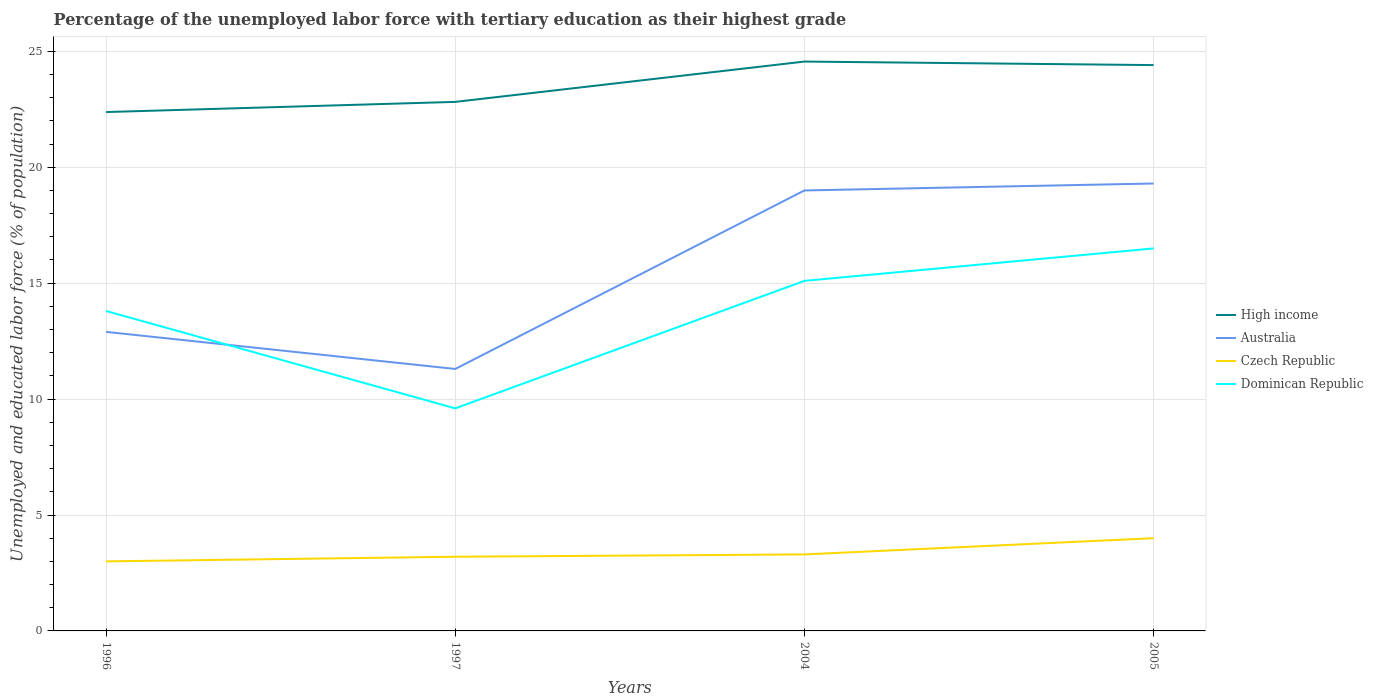Across all years, what is the maximum percentage of the unemployed labor force with tertiary education in Dominican Republic?
Make the answer very short. 9.6. What is the total percentage of the unemployed labor force with tertiary education in Australia in the graph?
Give a very brief answer. -8. What is the difference between the highest and the lowest percentage of the unemployed labor force with tertiary education in Dominican Republic?
Offer a very short reply. 3. How many years are there in the graph?
Your answer should be compact. 4. What is the difference between two consecutive major ticks on the Y-axis?
Ensure brevity in your answer.  5. How many legend labels are there?
Provide a succinct answer. 4. How are the legend labels stacked?
Offer a terse response. Vertical. What is the title of the graph?
Provide a short and direct response. Percentage of the unemployed labor force with tertiary education as their highest grade. Does "Lebanon" appear as one of the legend labels in the graph?
Your response must be concise. No. What is the label or title of the Y-axis?
Provide a short and direct response. Unemployed and educated labor force (% of population). What is the Unemployed and educated labor force (% of population) in High income in 1996?
Offer a very short reply. 22.38. What is the Unemployed and educated labor force (% of population) of Australia in 1996?
Ensure brevity in your answer.  12.9. What is the Unemployed and educated labor force (% of population) of Dominican Republic in 1996?
Offer a very short reply. 13.8. What is the Unemployed and educated labor force (% of population) of High income in 1997?
Make the answer very short. 22.82. What is the Unemployed and educated labor force (% of population) of Australia in 1997?
Provide a short and direct response. 11.3. What is the Unemployed and educated labor force (% of population) in Czech Republic in 1997?
Make the answer very short. 3.2. What is the Unemployed and educated labor force (% of population) of Dominican Republic in 1997?
Make the answer very short. 9.6. What is the Unemployed and educated labor force (% of population) of High income in 2004?
Offer a very short reply. 24.56. What is the Unemployed and educated labor force (% of population) of Australia in 2004?
Offer a very short reply. 19. What is the Unemployed and educated labor force (% of population) in Czech Republic in 2004?
Your response must be concise. 3.3. What is the Unemployed and educated labor force (% of population) of Dominican Republic in 2004?
Keep it short and to the point. 15.1. What is the Unemployed and educated labor force (% of population) of High income in 2005?
Offer a terse response. 24.41. What is the Unemployed and educated labor force (% of population) of Australia in 2005?
Provide a succinct answer. 19.3. What is the Unemployed and educated labor force (% of population) of Dominican Republic in 2005?
Your response must be concise. 16.5. Across all years, what is the maximum Unemployed and educated labor force (% of population) in High income?
Your response must be concise. 24.56. Across all years, what is the maximum Unemployed and educated labor force (% of population) of Australia?
Make the answer very short. 19.3. Across all years, what is the maximum Unemployed and educated labor force (% of population) in Czech Republic?
Offer a terse response. 4. Across all years, what is the maximum Unemployed and educated labor force (% of population) of Dominican Republic?
Your answer should be very brief. 16.5. Across all years, what is the minimum Unemployed and educated labor force (% of population) of High income?
Make the answer very short. 22.38. Across all years, what is the minimum Unemployed and educated labor force (% of population) of Australia?
Ensure brevity in your answer.  11.3. Across all years, what is the minimum Unemployed and educated labor force (% of population) of Dominican Republic?
Your response must be concise. 9.6. What is the total Unemployed and educated labor force (% of population) in High income in the graph?
Provide a short and direct response. 94.17. What is the total Unemployed and educated labor force (% of population) in Australia in the graph?
Your answer should be compact. 62.5. What is the total Unemployed and educated labor force (% of population) in Czech Republic in the graph?
Your answer should be very brief. 13.5. What is the total Unemployed and educated labor force (% of population) in Dominican Republic in the graph?
Your answer should be compact. 55. What is the difference between the Unemployed and educated labor force (% of population) in High income in 1996 and that in 1997?
Keep it short and to the point. -0.44. What is the difference between the Unemployed and educated labor force (% of population) in Australia in 1996 and that in 1997?
Make the answer very short. 1.6. What is the difference between the Unemployed and educated labor force (% of population) in Czech Republic in 1996 and that in 1997?
Offer a very short reply. -0.2. What is the difference between the Unemployed and educated labor force (% of population) in High income in 1996 and that in 2004?
Keep it short and to the point. -2.18. What is the difference between the Unemployed and educated labor force (% of population) of Czech Republic in 1996 and that in 2004?
Offer a terse response. -0.3. What is the difference between the Unemployed and educated labor force (% of population) in Dominican Republic in 1996 and that in 2004?
Provide a succinct answer. -1.3. What is the difference between the Unemployed and educated labor force (% of population) of High income in 1996 and that in 2005?
Offer a terse response. -2.03. What is the difference between the Unemployed and educated labor force (% of population) of Australia in 1996 and that in 2005?
Provide a short and direct response. -6.4. What is the difference between the Unemployed and educated labor force (% of population) in Czech Republic in 1996 and that in 2005?
Your answer should be compact. -1. What is the difference between the Unemployed and educated labor force (% of population) in Dominican Republic in 1996 and that in 2005?
Provide a succinct answer. -2.7. What is the difference between the Unemployed and educated labor force (% of population) in High income in 1997 and that in 2004?
Your response must be concise. -1.74. What is the difference between the Unemployed and educated labor force (% of population) in High income in 1997 and that in 2005?
Keep it short and to the point. -1.59. What is the difference between the Unemployed and educated labor force (% of population) in Australia in 1997 and that in 2005?
Offer a terse response. -8. What is the difference between the Unemployed and educated labor force (% of population) in Dominican Republic in 1997 and that in 2005?
Keep it short and to the point. -6.9. What is the difference between the Unemployed and educated labor force (% of population) of High income in 2004 and that in 2005?
Provide a succinct answer. 0.15. What is the difference between the Unemployed and educated labor force (% of population) of Australia in 2004 and that in 2005?
Provide a succinct answer. -0.3. What is the difference between the Unemployed and educated labor force (% of population) of Czech Republic in 2004 and that in 2005?
Offer a terse response. -0.7. What is the difference between the Unemployed and educated labor force (% of population) in Dominican Republic in 2004 and that in 2005?
Keep it short and to the point. -1.4. What is the difference between the Unemployed and educated labor force (% of population) in High income in 1996 and the Unemployed and educated labor force (% of population) in Australia in 1997?
Provide a succinct answer. 11.08. What is the difference between the Unemployed and educated labor force (% of population) of High income in 1996 and the Unemployed and educated labor force (% of population) of Czech Republic in 1997?
Offer a very short reply. 19.18. What is the difference between the Unemployed and educated labor force (% of population) in High income in 1996 and the Unemployed and educated labor force (% of population) in Dominican Republic in 1997?
Ensure brevity in your answer.  12.78. What is the difference between the Unemployed and educated labor force (% of population) of Australia in 1996 and the Unemployed and educated labor force (% of population) of Dominican Republic in 1997?
Your response must be concise. 3.3. What is the difference between the Unemployed and educated labor force (% of population) in Czech Republic in 1996 and the Unemployed and educated labor force (% of population) in Dominican Republic in 1997?
Keep it short and to the point. -6.6. What is the difference between the Unemployed and educated labor force (% of population) in High income in 1996 and the Unemployed and educated labor force (% of population) in Australia in 2004?
Your answer should be very brief. 3.38. What is the difference between the Unemployed and educated labor force (% of population) of High income in 1996 and the Unemployed and educated labor force (% of population) of Czech Republic in 2004?
Provide a succinct answer. 19.08. What is the difference between the Unemployed and educated labor force (% of population) in High income in 1996 and the Unemployed and educated labor force (% of population) in Dominican Republic in 2004?
Provide a short and direct response. 7.28. What is the difference between the Unemployed and educated labor force (% of population) of High income in 1996 and the Unemployed and educated labor force (% of population) of Australia in 2005?
Your answer should be very brief. 3.08. What is the difference between the Unemployed and educated labor force (% of population) in High income in 1996 and the Unemployed and educated labor force (% of population) in Czech Republic in 2005?
Give a very brief answer. 18.38. What is the difference between the Unemployed and educated labor force (% of population) of High income in 1996 and the Unemployed and educated labor force (% of population) of Dominican Republic in 2005?
Offer a terse response. 5.88. What is the difference between the Unemployed and educated labor force (% of population) in Australia in 1996 and the Unemployed and educated labor force (% of population) in Czech Republic in 2005?
Provide a succinct answer. 8.9. What is the difference between the Unemployed and educated labor force (% of population) of Australia in 1996 and the Unemployed and educated labor force (% of population) of Dominican Republic in 2005?
Make the answer very short. -3.6. What is the difference between the Unemployed and educated labor force (% of population) in Czech Republic in 1996 and the Unemployed and educated labor force (% of population) in Dominican Republic in 2005?
Ensure brevity in your answer.  -13.5. What is the difference between the Unemployed and educated labor force (% of population) in High income in 1997 and the Unemployed and educated labor force (% of population) in Australia in 2004?
Your answer should be compact. 3.82. What is the difference between the Unemployed and educated labor force (% of population) in High income in 1997 and the Unemployed and educated labor force (% of population) in Czech Republic in 2004?
Provide a succinct answer. 19.52. What is the difference between the Unemployed and educated labor force (% of population) in High income in 1997 and the Unemployed and educated labor force (% of population) in Dominican Republic in 2004?
Offer a very short reply. 7.72. What is the difference between the Unemployed and educated labor force (% of population) of Czech Republic in 1997 and the Unemployed and educated labor force (% of population) of Dominican Republic in 2004?
Offer a terse response. -11.9. What is the difference between the Unemployed and educated labor force (% of population) in High income in 1997 and the Unemployed and educated labor force (% of population) in Australia in 2005?
Offer a terse response. 3.52. What is the difference between the Unemployed and educated labor force (% of population) of High income in 1997 and the Unemployed and educated labor force (% of population) of Czech Republic in 2005?
Offer a very short reply. 18.82. What is the difference between the Unemployed and educated labor force (% of population) in High income in 1997 and the Unemployed and educated labor force (% of population) in Dominican Republic in 2005?
Ensure brevity in your answer.  6.32. What is the difference between the Unemployed and educated labor force (% of population) in Australia in 1997 and the Unemployed and educated labor force (% of population) in Dominican Republic in 2005?
Provide a succinct answer. -5.2. What is the difference between the Unemployed and educated labor force (% of population) in Czech Republic in 1997 and the Unemployed and educated labor force (% of population) in Dominican Republic in 2005?
Your response must be concise. -13.3. What is the difference between the Unemployed and educated labor force (% of population) of High income in 2004 and the Unemployed and educated labor force (% of population) of Australia in 2005?
Your answer should be compact. 5.26. What is the difference between the Unemployed and educated labor force (% of population) in High income in 2004 and the Unemployed and educated labor force (% of population) in Czech Republic in 2005?
Your answer should be very brief. 20.56. What is the difference between the Unemployed and educated labor force (% of population) in High income in 2004 and the Unemployed and educated labor force (% of population) in Dominican Republic in 2005?
Give a very brief answer. 8.06. What is the difference between the Unemployed and educated labor force (% of population) in Australia in 2004 and the Unemployed and educated labor force (% of population) in Dominican Republic in 2005?
Your answer should be compact. 2.5. What is the average Unemployed and educated labor force (% of population) in High income per year?
Offer a very short reply. 23.54. What is the average Unemployed and educated labor force (% of population) in Australia per year?
Provide a short and direct response. 15.62. What is the average Unemployed and educated labor force (% of population) in Czech Republic per year?
Provide a short and direct response. 3.38. What is the average Unemployed and educated labor force (% of population) of Dominican Republic per year?
Your answer should be compact. 13.75. In the year 1996, what is the difference between the Unemployed and educated labor force (% of population) of High income and Unemployed and educated labor force (% of population) of Australia?
Offer a terse response. 9.48. In the year 1996, what is the difference between the Unemployed and educated labor force (% of population) of High income and Unemployed and educated labor force (% of population) of Czech Republic?
Provide a short and direct response. 19.38. In the year 1996, what is the difference between the Unemployed and educated labor force (% of population) of High income and Unemployed and educated labor force (% of population) of Dominican Republic?
Keep it short and to the point. 8.58. In the year 1996, what is the difference between the Unemployed and educated labor force (% of population) of Australia and Unemployed and educated labor force (% of population) of Czech Republic?
Make the answer very short. 9.9. In the year 1996, what is the difference between the Unemployed and educated labor force (% of population) of Australia and Unemployed and educated labor force (% of population) of Dominican Republic?
Provide a short and direct response. -0.9. In the year 1997, what is the difference between the Unemployed and educated labor force (% of population) of High income and Unemployed and educated labor force (% of population) of Australia?
Offer a terse response. 11.52. In the year 1997, what is the difference between the Unemployed and educated labor force (% of population) of High income and Unemployed and educated labor force (% of population) of Czech Republic?
Your answer should be compact. 19.62. In the year 1997, what is the difference between the Unemployed and educated labor force (% of population) in High income and Unemployed and educated labor force (% of population) in Dominican Republic?
Ensure brevity in your answer.  13.22. In the year 2004, what is the difference between the Unemployed and educated labor force (% of population) in High income and Unemployed and educated labor force (% of population) in Australia?
Offer a terse response. 5.56. In the year 2004, what is the difference between the Unemployed and educated labor force (% of population) in High income and Unemployed and educated labor force (% of population) in Czech Republic?
Make the answer very short. 21.26. In the year 2004, what is the difference between the Unemployed and educated labor force (% of population) of High income and Unemployed and educated labor force (% of population) of Dominican Republic?
Provide a succinct answer. 9.46. In the year 2005, what is the difference between the Unemployed and educated labor force (% of population) in High income and Unemployed and educated labor force (% of population) in Australia?
Offer a very short reply. 5.11. In the year 2005, what is the difference between the Unemployed and educated labor force (% of population) of High income and Unemployed and educated labor force (% of population) of Czech Republic?
Your response must be concise. 20.41. In the year 2005, what is the difference between the Unemployed and educated labor force (% of population) of High income and Unemployed and educated labor force (% of population) of Dominican Republic?
Your answer should be compact. 7.91. In the year 2005, what is the difference between the Unemployed and educated labor force (% of population) of Australia and Unemployed and educated labor force (% of population) of Dominican Republic?
Provide a succinct answer. 2.8. In the year 2005, what is the difference between the Unemployed and educated labor force (% of population) of Czech Republic and Unemployed and educated labor force (% of population) of Dominican Republic?
Offer a terse response. -12.5. What is the ratio of the Unemployed and educated labor force (% of population) of High income in 1996 to that in 1997?
Your response must be concise. 0.98. What is the ratio of the Unemployed and educated labor force (% of population) of Australia in 1996 to that in 1997?
Your answer should be compact. 1.14. What is the ratio of the Unemployed and educated labor force (% of population) of Dominican Republic in 1996 to that in 1997?
Your answer should be very brief. 1.44. What is the ratio of the Unemployed and educated labor force (% of population) in High income in 1996 to that in 2004?
Provide a short and direct response. 0.91. What is the ratio of the Unemployed and educated labor force (% of population) of Australia in 1996 to that in 2004?
Make the answer very short. 0.68. What is the ratio of the Unemployed and educated labor force (% of population) of Dominican Republic in 1996 to that in 2004?
Provide a succinct answer. 0.91. What is the ratio of the Unemployed and educated labor force (% of population) of High income in 1996 to that in 2005?
Offer a terse response. 0.92. What is the ratio of the Unemployed and educated labor force (% of population) of Australia in 1996 to that in 2005?
Your answer should be compact. 0.67. What is the ratio of the Unemployed and educated labor force (% of population) of Dominican Republic in 1996 to that in 2005?
Provide a succinct answer. 0.84. What is the ratio of the Unemployed and educated labor force (% of population) of High income in 1997 to that in 2004?
Offer a very short reply. 0.93. What is the ratio of the Unemployed and educated labor force (% of population) in Australia in 1997 to that in 2004?
Ensure brevity in your answer.  0.59. What is the ratio of the Unemployed and educated labor force (% of population) in Czech Republic in 1997 to that in 2004?
Your answer should be compact. 0.97. What is the ratio of the Unemployed and educated labor force (% of population) of Dominican Republic in 1997 to that in 2004?
Your answer should be very brief. 0.64. What is the ratio of the Unemployed and educated labor force (% of population) in High income in 1997 to that in 2005?
Provide a succinct answer. 0.94. What is the ratio of the Unemployed and educated labor force (% of population) of Australia in 1997 to that in 2005?
Make the answer very short. 0.59. What is the ratio of the Unemployed and educated labor force (% of population) in Dominican Republic in 1997 to that in 2005?
Offer a very short reply. 0.58. What is the ratio of the Unemployed and educated labor force (% of population) of High income in 2004 to that in 2005?
Give a very brief answer. 1.01. What is the ratio of the Unemployed and educated labor force (% of population) in Australia in 2004 to that in 2005?
Make the answer very short. 0.98. What is the ratio of the Unemployed and educated labor force (% of population) in Czech Republic in 2004 to that in 2005?
Make the answer very short. 0.82. What is the ratio of the Unemployed and educated labor force (% of population) of Dominican Republic in 2004 to that in 2005?
Ensure brevity in your answer.  0.92. What is the difference between the highest and the second highest Unemployed and educated labor force (% of population) of High income?
Provide a succinct answer. 0.15. What is the difference between the highest and the second highest Unemployed and educated labor force (% of population) of Czech Republic?
Give a very brief answer. 0.7. What is the difference between the highest and the lowest Unemployed and educated labor force (% of population) in High income?
Ensure brevity in your answer.  2.18. What is the difference between the highest and the lowest Unemployed and educated labor force (% of population) of Australia?
Your response must be concise. 8. What is the difference between the highest and the lowest Unemployed and educated labor force (% of population) in Czech Republic?
Make the answer very short. 1. 